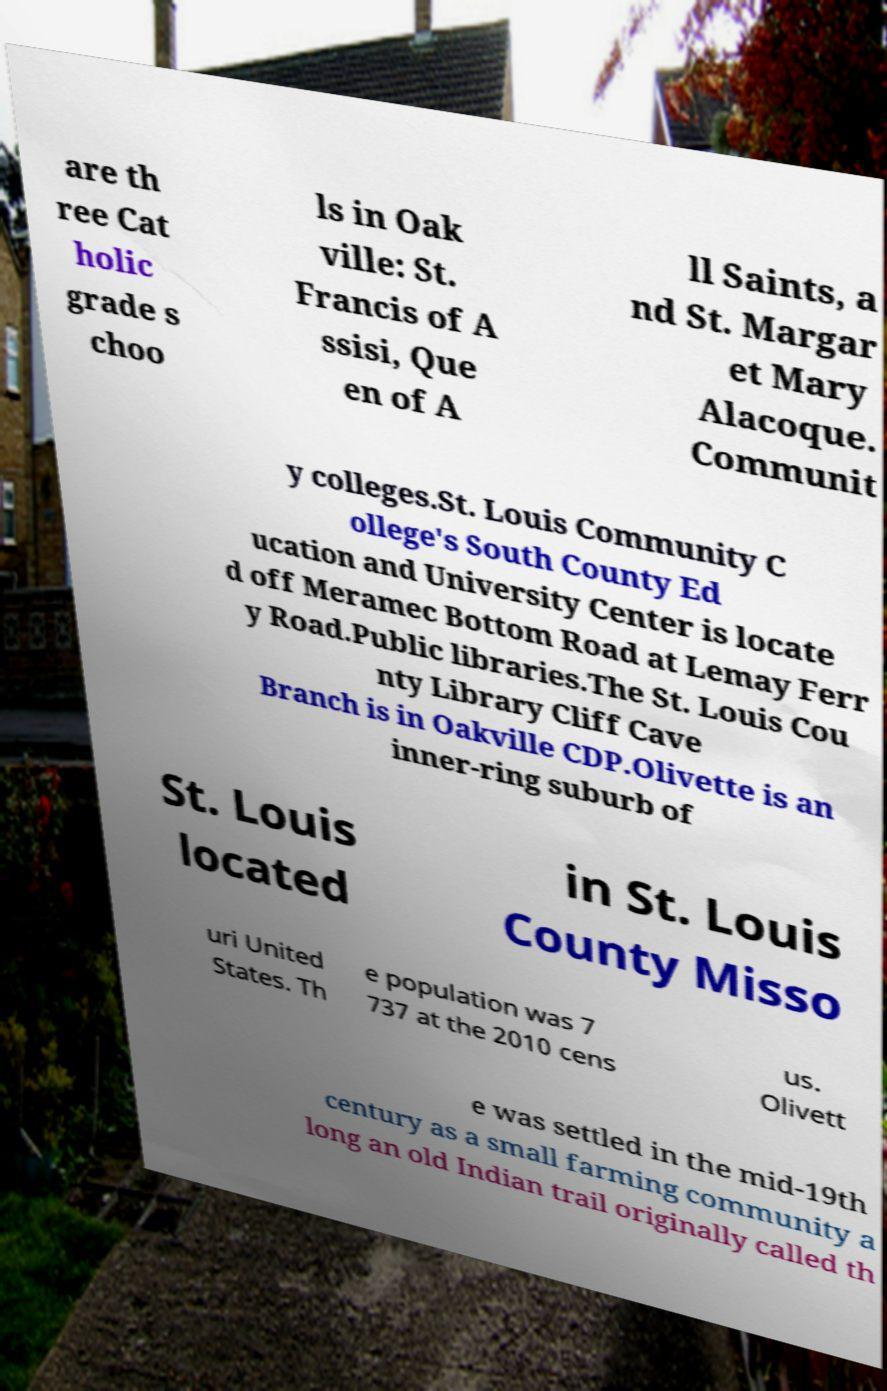Please identify and transcribe the text found in this image. are th ree Cat holic grade s choo ls in Oak ville: St. Francis of A ssisi, Que en of A ll Saints, a nd St. Margar et Mary Alacoque. Communit y colleges.St. Louis Community C ollege's South County Ed ucation and University Center is locate d off Meramec Bottom Road at Lemay Ferr y Road.Public libraries.The St. Louis Cou nty Library Cliff Cave Branch is in Oakville CDP.Olivette is an inner-ring suburb of St. Louis located in St. Louis County Misso uri United States. Th e population was 7 737 at the 2010 cens us. Olivett e was settled in the mid-19th century as a small farming community a long an old Indian trail originally called th 